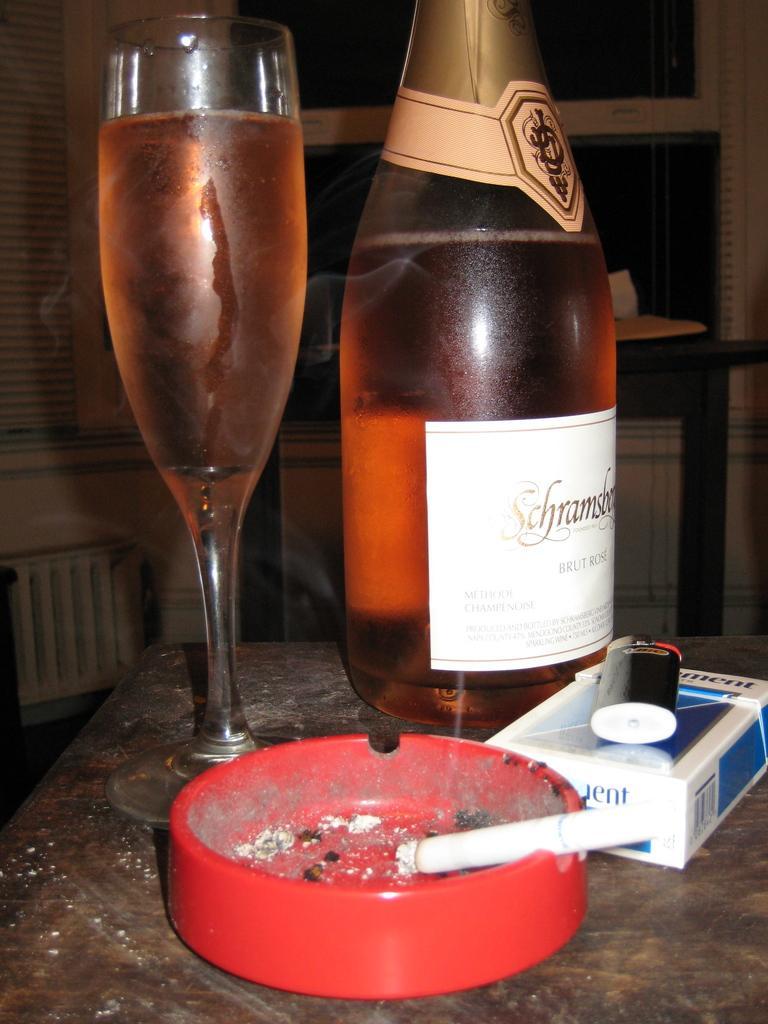Can you describe this image briefly? There is a glass and bottle on the table. They are filled with drink. There is cigarette and cigarettes box are on the table. In the background, there is a wall. 